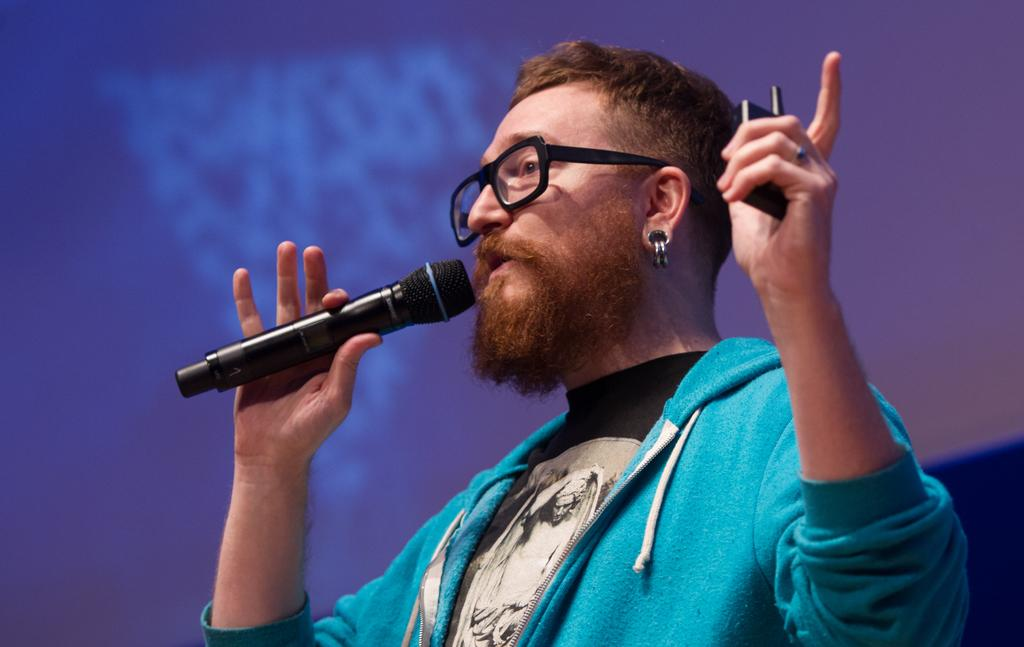Who is present in the image? There is a man in the image. What is the man wearing? The man is wearing a blue jacket. What is the man holding in the image? The man is holding a mic. What can be seen in the background of the image? There is a screen in the background of the image. What color is the screen? The screen is blue in color. What type of cork can be seen on the man's sweater in the image? There is no cork or sweater present in the image; the man is wearing a blue jacket. 